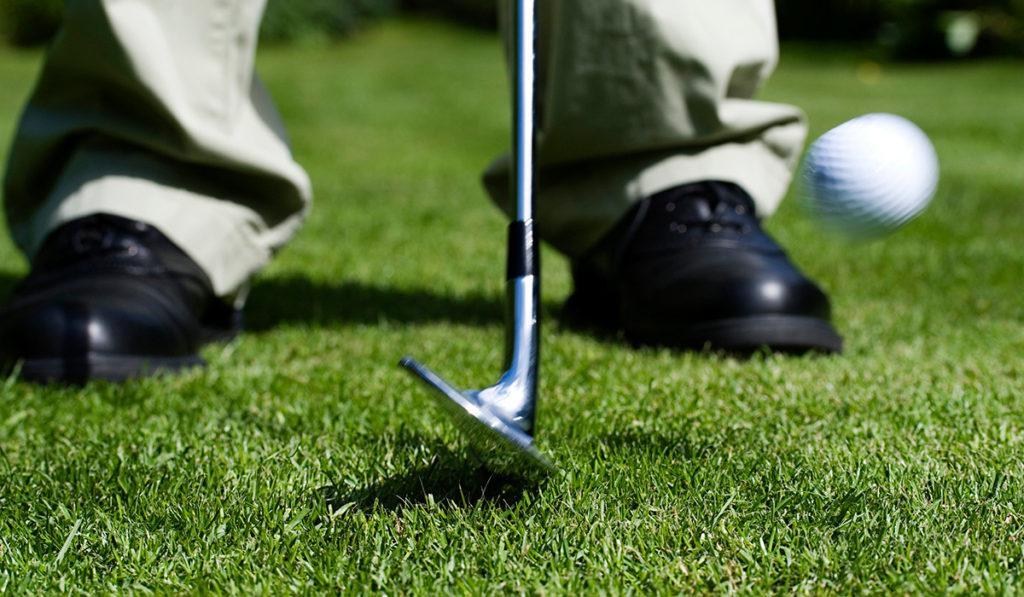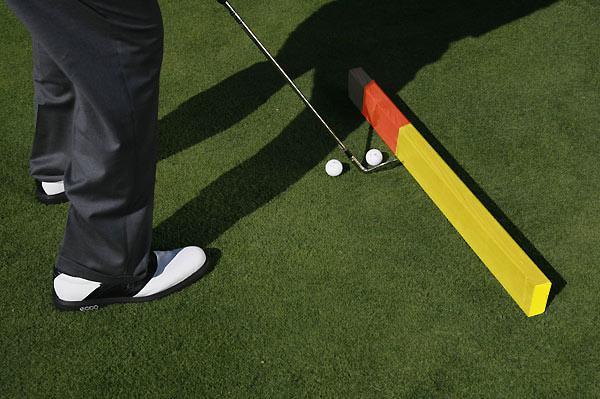The first image is the image on the left, the second image is the image on the right. Examine the images to the left and right. Is the description "The left image contains exactly three golf balls." accurate? Answer yes or no. No. The first image is the image on the left, the second image is the image on the right. Given the left and right images, does the statement "One image shows a golf club and three balls, but no part of a golfer." hold true? Answer yes or no. No. 